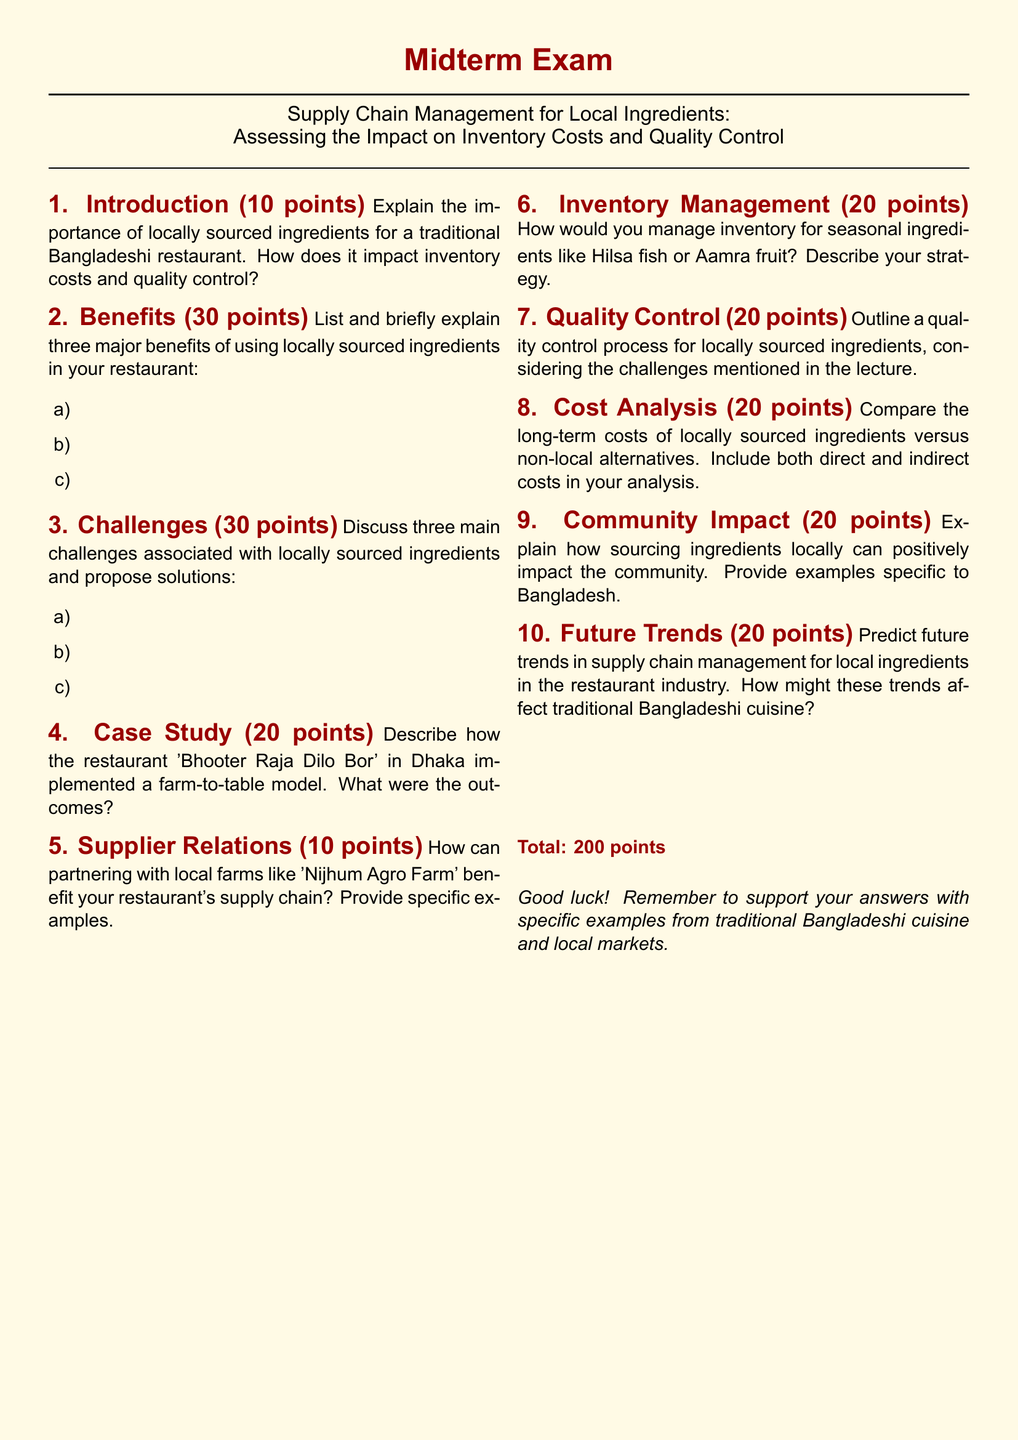What is the title of the midterm exam? The title of the midterm exam is mentioned at the beginning of the document, detailing its focus on supply chain management for local ingredients.
Answer: Supply Chain Management for Local Ingredients: Assessing the Impact on Inventory Costs and Quality Control How many points is the section on Introduction worth? The points assigned to the Introduction section are specifically noted in the document.
Answer: 10 points What is one of the challenges associated with locally sourced ingredients? The document outlines challenges related to sourcing locally, which are discussed in the challenges section.
Answer: [Any reasonable challenge mentioned in the document] Name a restaurant referenced in the case study section. The document specifies a restaurant that serves as an example in the case study section.
Answer: Bhooter Raja Dilo Bor How many benefits of using locally sourced ingredients are to be listed in the exam? The instructions in the document clearly state the number of benefits that students need to address.
Answer: Three What is the maximum total score for this midterm exam? The document provides the total points possible for the exam at the end of the text.
Answer: 200 points Identify one local farm mentioned as a potential partner for supply chain benefits. One local farm that is highlighted in the document for potential partnerships is named explicitly.
Answer: Nijhum Agro Farm How many points are dedicated to the Future Trends section? The document indicates the point allocation for each section, including Future Trends.
Answer: 20 points What should students remember to support their answers with? The document provides a reminder for students regarding what they should include in their answers.
Answer: Specific examples from traditional Bangladeshi cuisine and local markets 